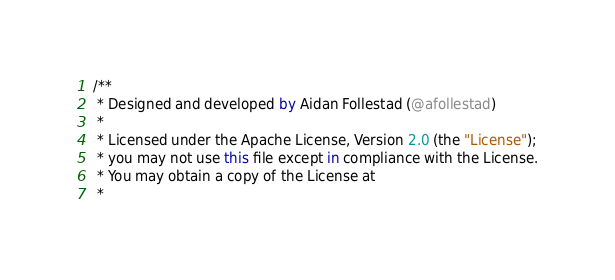<code> <loc_0><loc_0><loc_500><loc_500><_Kotlin_>/**
 * Designed and developed by Aidan Follestad (@afollestad)
 *
 * Licensed under the Apache License, Version 2.0 (the "License");
 * you may not use this file except in compliance with the License.
 * You may obtain a copy of the License at
 *</code> 